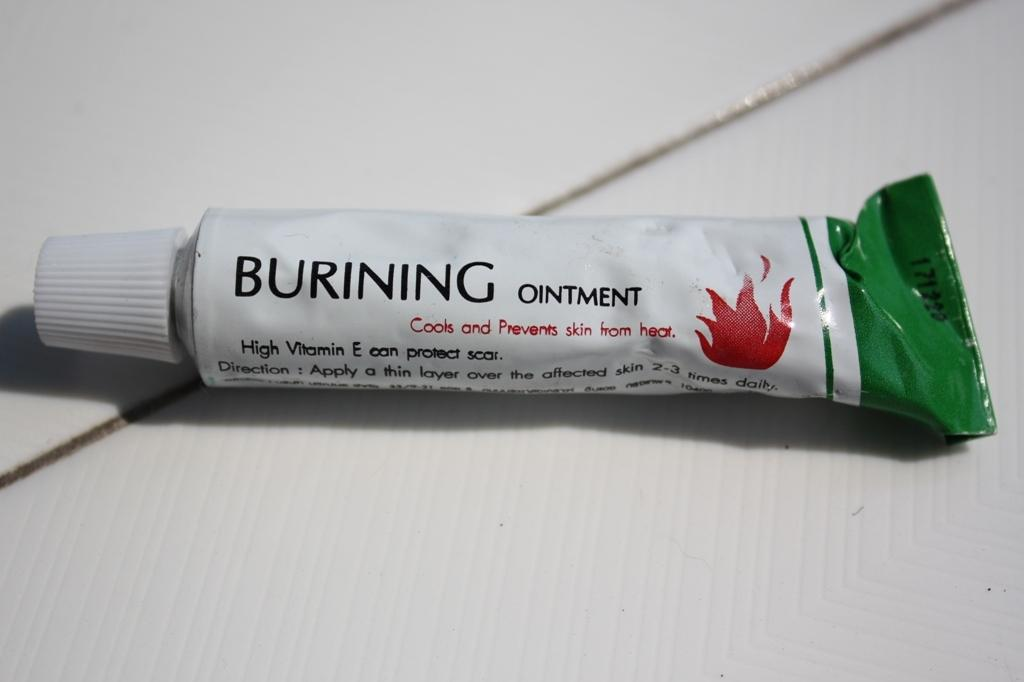Provide a one-sentence caption for the provided image. A tube of Burning ointment with vitamin e to stop heat from harming skin. 